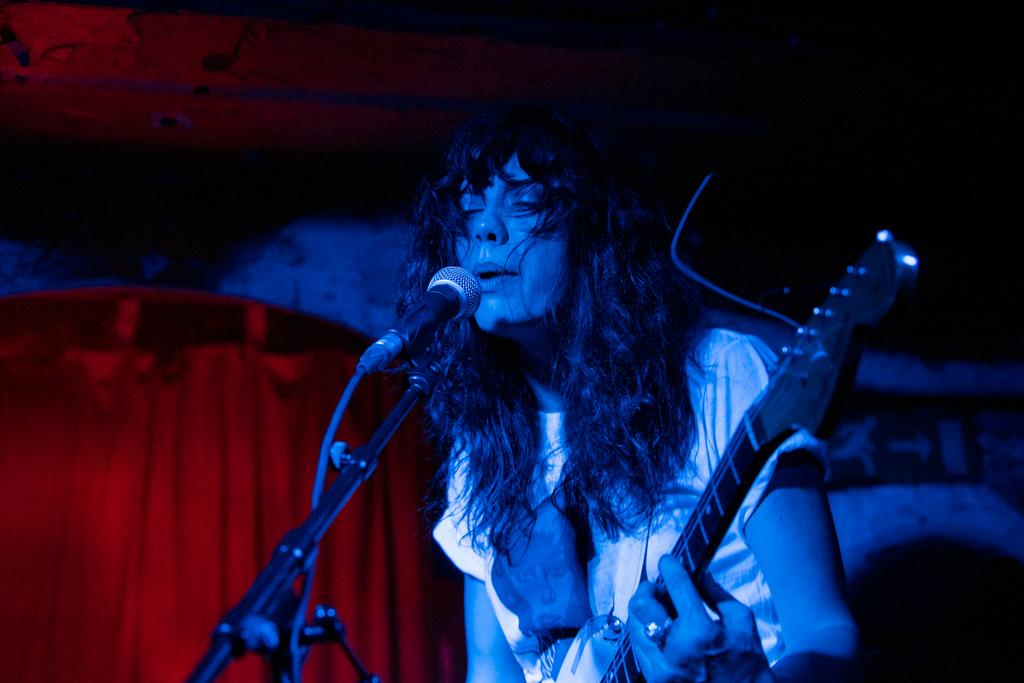What type of event is depicted in the image? The image is from a musical concert. Who is the main subject in the image? There is a woman in the middle of the image. What is the woman doing in the image? The woman is playing a guitar. What is the woman using to amplify her voice in the image? There is a microphone in front of the woman. What can be seen on the left side of the image? There is a red curtain on the left side of the image. What is the rate of the letters falling from the sky in the image? There are no letters falling from the sky in the image. 